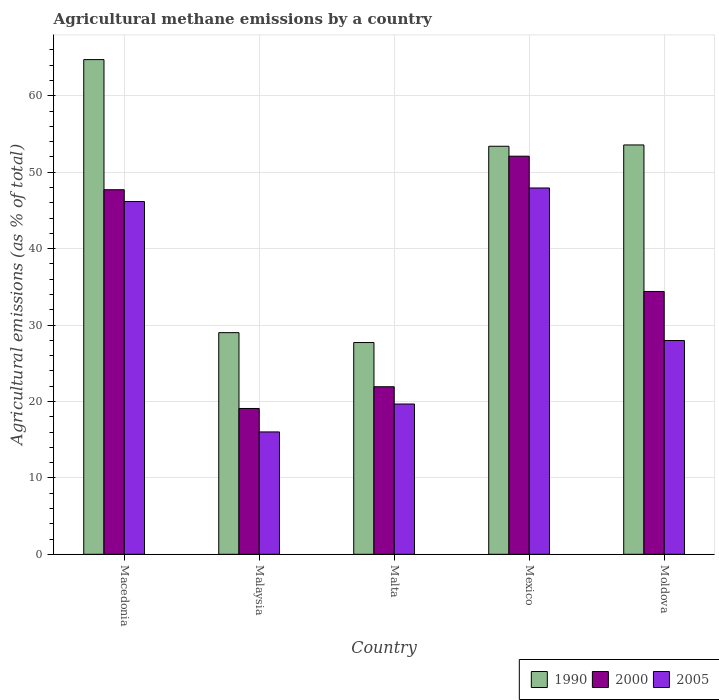How many groups of bars are there?
Your answer should be compact. 5. How many bars are there on the 1st tick from the right?
Keep it short and to the point. 3. What is the label of the 5th group of bars from the left?
Your response must be concise. Moldova. In how many cases, is the number of bars for a given country not equal to the number of legend labels?
Make the answer very short. 0. What is the amount of agricultural methane emitted in 1990 in Malta?
Make the answer very short. 27.71. Across all countries, what is the maximum amount of agricultural methane emitted in 2000?
Your answer should be very brief. 52.09. Across all countries, what is the minimum amount of agricultural methane emitted in 2000?
Your response must be concise. 19.08. In which country was the amount of agricultural methane emitted in 1990 maximum?
Your answer should be very brief. Macedonia. In which country was the amount of agricultural methane emitted in 2000 minimum?
Give a very brief answer. Malaysia. What is the total amount of agricultural methane emitted in 1990 in the graph?
Make the answer very short. 228.4. What is the difference between the amount of agricultural methane emitted in 2005 in Mexico and that in Moldova?
Ensure brevity in your answer.  19.96. What is the difference between the amount of agricultural methane emitted in 2005 in Malta and the amount of agricultural methane emitted in 2000 in Moldova?
Provide a succinct answer. -14.72. What is the average amount of agricultural methane emitted in 2005 per country?
Provide a short and direct response. 31.55. What is the difference between the amount of agricultural methane emitted of/in 2000 and amount of agricultural methane emitted of/in 2005 in Mexico?
Your answer should be very brief. 4.16. What is the ratio of the amount of agricultural methane emitted in 1990 in Macedonia to that in Malaysia?
Give a very brief answer. 2.23. Is the amount of agricultural methane emitted in 1990 in Macedonia less than that in Mexico?
Ensure brevity in your answer.  No. Is the difference between the amount of agricultural methane emitted in 2000 in Malta and Moldova greater than the difference between the amount of agricultural methane emitted in 2005 in Malta and Moldova?
Ensure brevity in your answer.  No. What is the difference between the highest and the second highest amount of agricultural methane emitted in 2005?
Offer a very short reply. -18.19. What is the difference between the highest and the lowest amount of agricultural methane emitted in 1990?
Your response must be concise. 37.02. In how many countries, is the amount of agricultural methane emitted in 1990 greater than the average amount of agricultural methane emitted in 1990 taken over all countries?
Give a very brief answer. 3. Is the sum of the amount of agricultural methane emitted in 2005 in Macedonia and Malta greater than the maximum amount of agricultural methane emitted in 2000 across all countries?
Keep it short and to the point. Yes. Are all the bars in the graph horizontal?
Give a very brief answer. No. How many countries are there in the graph?
Offer a very short reply. 5. Are the values on the major ticks of Y-axis written in scientific E-notation?
Provide a succinct answer. No. Does the graph contain grids?
Your answer should be very brief. Yes. Where does the legend appear in the graph?
Provide a succinct answer. Bottom right. How many legend labels are there?
Offer a very short reply. 3. What is the title of the graph?
Provide a succinct answer. Agricultural methane emissions by a country. Does "2001" appear as one of the legend labels in the graph?
Ensure brevity in your answer.  No. What is the label or title of the Y-axis?
Give a very brief answer. Agricultural emissions (as % of total). What is the Agricultural emissions (as % of total) in 1990 in Macedonia?
Provide a succinct answer. 64.73. What is the Agricultural emissions (as % of total) in 2000 in Macedonia?
Provide a short and direct response. 47.7. What is the Agricultural emissions (as % of total) in 2005 in Macedonia?
Make the answer very short. 46.16. What is the Agricultural emissions (as % of total) in 1990 in Malaysia?
Ensure brevity in your answer.  29. What is the Agricultural emissions (as % of total) in 2000 in Malaysia?
Give a very brief answer. 19.08. What is the Agricultural emissions (as % of total) in 2005 in Malaysia?
Your answer should be very brief. 16.01. What is the Agricultural emissions (as % of total) of 1990 in Malta?
Your answer should be compact. 27.71. What is the Agricultural emissions (as % of total) of 2000 in Malta?
Make the answer very short. 21.92. What is the Agricultural emissions (as % of total) of 2005 in Malta?
Make the answer very short. 19.67. What is the Agricultural emissions (as % of total) in 1990 in Mexico?
Provide a succinct answer. 53.39. What is the Agricultural emissions (as % of total) in 2000 in Mexico?
Make the answer very short. 52.09. What is the Agricultural emissions (as % of total) of 2005 in Mexico?
Offer a terse response. 47.93. What is the Agricultural emissions (as % of total) in 1990 in Moldova?
Give a very brief answer. 53.56. What is the Agricultural emissions (as % of total) of 2000 in Moldova?
Offer a very short reply. 34.39. What is the Agricultural emissions (as % of total) of 2005 in Moldova?
Your answer should be very brief. 27.97. Across all countries, what is the maximum Agricultural emissions (as % of total) of 1990?
Provide a succinct answer. 64.73. Across all countries, what is the maximum Agricultural emissions (as % of total) of 2000?
Give a very brief answer. 52.09. Across all countries, what is the maximum Agricultural emissions (as % of total) of 2005?
Your answer should be very brief. 47.93. Across all countries, what is the minimum Agricultural emissions (as % of total) in 1990?
Offer a terse response. 27.71. Across all countries, what is the minimum Agricultural emissions (as % of total) of 2000?
Provide a short and direct response. 19.08. Across all countries, what is the minimum Agricultural emissions (as % of total) of 2005?
Keep it short and to the point. 16.01. What is the total Agricultural emissions (as % of total) in 1990 in the graph?
Your answer should be very brief. 228.4. What is the total Agricultural emissions (as % of total) of 2000 in the graph?
Provide a succinct answer. 175.19. What is the total Agricultural emissions (as % of total) in 2005 in the graph?
Make the answer very short. 157.74. What is the difference between the Agricultural emissions (as % of total) of 1990 in Macedonia and that in Malaysia?
Provide a succinct answer. 35.73. What is the difference between the Agricultural emissions (as % of total) in 2000 in Macedonia and that in Malaysia?
Your response must be concise. 28.63. What is the difference between the Agricultural emissions (as % of total) in 2005 in Macedonia and that in Malaysia?
Keep it short and to the point. 30.15. What is the difference between the Agricultural emissions (as % of total) of 1990 in Macedonia and that in Malta?
Offer a very short reply. 37.02. What is the difference between the Agricultural emissions (as % of total) of 2000 in Macedonia and that in Malta?
Offer a very short reply. 25.78. What is the difference between the Agricultural emissions (as % of total) in 2005 in Macedonia and that in Malta?
Provide a succinct answer. 26.49. What is the difference between the Agricultural emissions (as % of total) of 1990 in Macedonia and that in Mexico?
Your answer should be compact. 11.34. What is the difference between the Agricultural emissions (as % of total) in 2000 in Macedonia and that in Mexico?
Make the answer very short. -4.39. What is the difference between the Agricultural emissions (as % of total) in 2005 in Macedonia and that in Mexico?
Your response must be concise. -1.77. What is the difference between the Agricultural emissions (as % of total) in 1990 in Macedonia and that in Moldova?
Offer a very short reply. 11.17. What is the difference between the Agricultural emissions (as % of total) of 2000 in Macedonia and that in Moldova?
Your answer should be compact. 13.31. What is the difference between the Agricultural emissions (as % of total) in 2005 in Macedonia and that in Moldova?
Provide a short and direct response. 18.19. What is the difference between the Agricultural emissions (as % of total) of 1990 in Malaysia and that in Malta?
Ensure brevity in your answer.  1.29. What is the difference between the Agricultural emissions (as % of total) in 2000 in Malaysia and that in Malta?
Offer a terse response. -2.84. What is the difference between the Agricultural emissions (as % of total) of 2005 in Malaysia and that in Malta?
Your answer should be very brief. -3.65. What is the difference between the Agricultural emissions (as % of total) in 1990 in Malaysia and that in Mexico?
Offer a terse response. -24.39. What is the difference between the Agricultural emissions (as % of total) in 2000 in Malaysia and that in Mexico?
Give a very brief answer. -33.01. What is the difference between the Agricultural emissions (as % of total) of 2005 in Malaysia and that in Mexico?
Your response must be concise. -31.92. What is the difference between the Agricultural emissions (as % of total) in 1990 in Malaysia and that in Moldova?
Offer a terse response. -24.56. What is the difference between the Agricultural emissions (as % of total) in 2000 in Malaysia and that in Moldova?
Give a very brief answer. -15.31. What is the difference between the Agricultural emissions (as % of total) of 2005 in Malaysia and that in Moldova?
Make the answer very short. -11.96. What is the difference between the Agricultural emissions (as % of total) of 1990 in Malta and that in Mexico?
Your answer should be compact. -25.68. What is the difference between the Agricultural emissions (as % of total) in 2000 in Malta and that in Mexico?
Provide a short and direct response. -30.17. What is the difference between the Agricultural emissions (as % of total) of 2005 in Malta and that in Mexico?
Provide a succinct answer. -28.27. What is the difference between the Agricultural emissions (as % of total) of 1990 in Malta and that in Moldova?
Your answer should be very brief. -25.85. What is the difference between the Agricultural emissions (as % of total) of 2000 in Malta and that in Moldova?
Your answer should be compact. -12.47. What is the difference between the Agricultural emissions (as % of total) in 2005 in Malta and that in Moldova?
Ensure brevity in your answer.  -8.3. What is the difference between the Agricultural emissions (as % of total) of 1990 in Mexico and that in Moldova?
Your response must be concise. -0.17. What is the difference between the Agricultural emissions (as % of total) of 2000 in Mexico and that in Moldova?
Keep it short and to the point. 17.7. What is the difference between the Agricultural emissions (as % of total) of 2005 in Mexico and that in Moldova?
Provide a succinct answer. 19.96. What is the difference between the Agricultural emissions (as % of total) of 1990 in Macedonia and the Agricultural emissions (as % of total) of 2000 in Malaysia?
Provide a succinct answer. 45.65. What is the difference between the Agricultural emissions (as % of total) in 1990 in Macedonia and the Agricultural emissions (as % of total) in 2005 in Malaysia?
Ensure brevity in your answer.  48.72. What is the difference between the Agricultural emissions (as % of total) in 2000 in Macedonia and the Agricultural emissions (as % of total) in 2005 in Malaysia?
Make the answer very short. 31.69. What is the difference between the Agricultural emissions (as % of total) of 1990 in Macedonia and the Agricultural emissions (as % of total) of 2000 in Malta?
Offer a very short reply. 42.81. What is the difference between the Agricultural emissions (as % of total) in 1990 in Macedonia and the Agricultural emissions (as % of total) in 2005 in Malta?
Provide a short and direct response. 45.06. What is the difference between the Agricultural emissions (as % of total) in 2000 in Macedonia and the Agricultural emissions (as % of total) in 2005 in Malta?
Your answer should be very brief. 28.04. What is the difference between the Agricultural emissions (as % of total) of 1990 in Macedonia and the Agricultural emissions (as % of total) of 2000 in Mexico?
Offer a terse response. 12.64. What is the difference between the Agricultural emissions (as % of total) in 1990 in Macedonia and the Agricultural emissions (as % of total) in 2005 in Mexico?
Keep it short and to the point. 16.8. What is the difference between the Agricultural emissions (as % of total) of 2000 in Macedonia and the Agricultural emissions (as % of total) of 2005 in Mexico?
Your answer should be very brief. -0.23. What is the difference between the Agricultural emissions (as % of total) in 1990 in Macedonia and the Agricultural emissions (as % of total) in 2000 in Moldova?
Your response must be concise. 30.34. What is the difference between the Agricultural emissions (as % of total) of 1990 in Macedonia and the Agricultural emissions (as % of total) of 2005 in Moldova?
Provide a short and direct response. 36.76. What is the difference between the Agricultural emissions (as % of total) of 2000 in Macedonia and the Agricultural emissions (as % of total) of 2005 in Moldova?
Your response must be concise. 19.73. What is the difference between the Agricultural emissions (as % of total) in 1990 in Malaysia and the Agricultural emissions (as % of total) in 2000 in Malta?
Ensure brevity in your answer.  7.08. What is the difference between the Agricultural emissions (as % of total) of 1990 in Malaysia and the Agricultural emissions (as % of total) of 2005 in Malta?
Give a very brief answer. 9.34. What is the difference between the Agricultural emissions (as % of total) in 2000 in Malaysia and the Agricultural emissions (as % of total) in 2005 in Malta?
Your answer should be very brief. -0.59. What is the difference between the Agricultural emissions (as % of total) in 1990 in Malaysia and the Agricultural emissions (as % of total) in 2000 in Mexico?
Make the answer very short. -23.09. What is the difference between the Agricultural emissions (as % of total) in 1990 in Malaysia and the Agricultural emissions (as % of total) in 2005 in Mexico?
Give a very brief answer. -18.93. What is the difference between the Agricultural emissions (as % of total) of 2000 in Malaysia and the Agricultural emissions (as % of total) of 2005 in Mexico?
Provide a succinct answer. -28.85. What is the difference between the Agricultural emissions (as % of total) in 1990 in Malaysia and the Agricultural emissions (as % of total) in 2000 in Moldova?
Give a very brief answer. -5.39. What is the difference between the Agricultural emissions (as % of total) of 1990 in Malaysia and the Agricultural emissions (as % of total) of 2005 in Moldova?
Provide a short and direct response. 1.03. What is the difference between the Agricultural emissions (as % of total) of 2000 in Malaysia and the Agricultural emissions (as % of total) of 2005 in Moldova?
Provide a succinct answer. -8.89. What is the difference between the Agricultural emissions (as % of total) of 1990 in Malta and the Agricultural emissions (as % of total) of 2000 in Mexico?
Your answer should be very brief. -24.38. What is the difference between the Agricultural emissions (as % of total) of 1990 in Malta and the Agricultural emissions (as % of total) of 2005 in Mexico?
Give a very brief answer. -20.22. What is the difference between the Agricultural emissions (as % of total) of 2000 in Malta and the Agricultural emissions (as % of total) of 2005 in Mexico?
Keep it short and to the point. -26.01. What is the difference between the Agricultural emissions (as % of total) of 1990 in Malta and the Agricultural emissions (as % of total) of 2000 in Moldova?
Offer a terse response. -6.68. What is the difference between the Agricultural emissions (as % of total) of 1990 in Malta and the Agricultural emissions (as % of total) of 2005 in Moldova?
Your response must be concise. -0.26. What is the difference between the Agricultural emissions (as % of total) of 2000 in Malta and the Agricultural emissions (as % of total) of 2005 in Moldova?
Offer a very short reply. -6.05. What is the difference between the Agricultural emissions (as % of total) of 1990 in Mexico and the Agricultural emissions (as % of total) of 2000 in Moldova?
Give a very brief answer. 19. What is the difference between the Agricultural emissions (as % of total) of 1990 in Mexico and the Agricultural emissions (as % of total) of 2005 in Moldova?
Your answer should be compact. 25.42. What is the difference between the Agricultural emissions (as % of total) of 2000 in Mexico and the Agricultural emissions (as % of total) of 2005 in Moldova?
Keep it short and to the point. 24.12. What is the average Agricultural emissions (as % of total) in 1990 per country?
Ensure brevity in your answer.  45.68. What is the average Agricultural emissions (as % of total) of 2000 per country?
Provide a short and direct response. 35.04. What is the average Agricultural emissions (as % of total) in 2005 per country?
Provide a succinct answer. 31.55. What is the difference between the Agricultural emissions (as % of total) in 1990 and Agricultural emissions (as % of total) in 2000 in Macedonia?
Ensure brevity in your answer.  17.03. What is the difference between the Agricultural emissions (as % of total) in 1990 and Agricultural emissions (as % of total) in 2005 in Macedonia?
Ensure brevity in your answer.  18.57. What is the difference between the Agricultural emissions (as % of total) in 2000 and Agricultural emissions (as % of total) in 2005 in Macedonia?
Offer a very short reply. 1.55. What is the difference between the Agricultural emissions (as % of total) in 1990 and Agricultural emissions (as % of total) in 2000 in Malaysia?
Make the answer very short. 9.92. What is the difference between the Agricultural emissions (as % of total) in 1990 and Agricultural emissions (as % of total) in 2005 in Malaysia?
Your response must be concise. 12.99. What is the difference between the Agricultural emissions (as % of total) in 2000 and Agricultural emissions (as % of total) in 2005 in Malaysia?
Keep it short and to the point. 3.07. What is the difference between the Agricultural emissions (as % of total) of 1990 and Agricultural emissions (as % of total) of 2000 in Malta?
Ensure brevity in your answer.  5.78. What is the difference between the Agricultural emissions (as % of total) of 1990 and Agricultural emissions (as % of total) of 2005 in Malta?
Your answer should be compact. 8.04. What is the difference between the Agricultural emissions (as % of total) of 2000 and Agricultural emissions (as % of total) of 2005 in Malta?
Offer a very short reply. 2.26. What is the difference between the Agricultural emissions (as % of total) in 1990 and Agricultural emissions (as % of total) in 2000 in Mexico?
Make the answer very short. 1.3. What is the difference between the Agricultural emissions (as % of total) in 1990 and Agricultural emissions (as % of total) in 2005 in Mexico?
Provide a short and direct response. 5.46. What is the difference between the Agricultural emissions (as % of total) in 2000 and Agricultural emissions (as % of total) in 2005 in Mexico?
Keep it short and to the point. 4.16. What is the difference between the Agricultural emissions (as % of total) of 1990 and Agricultural emissions (as % of total) of 2000 in Moldova?
Make the answer very short. 19.17. What is the difference between the Agricultural emissions (as % of total) of 1990 and Agricultural emissions (as % of total) of 2005 in Moldova?
Your response must be concise. 25.59. What is the difference between the Agricultural emissions (as % of total) of 2000 and Agricultural emissions (as % of total) of 2005 in Moldova?
Offer a very short reply. 6.42. What is the ratio of the Agricultural emissions (as % of total) of 1990 in Macedonia to that in Malaysia?
Give a very brief answer. 2.23. What is the ratio of the Agricultural emissions (as % of total) in 2000 in Macedonia to that in Malaysia?
Your response must be concise. 2.5. What is the ratio of the Agricultural emissions (as % of total) in 2005 in Macedonia to that in Malaysia?
Provide a succinct answer. 2.88. What is the ratio of the Agricultural emissions (as % of total) in 1990 in Macedonia to that in Malta?
Keep it short and to the point. 2.34. What is the ratio of the Agricultural emissions (as % of total) in 2000 in Macedonia to that in Malta?
Ensure brevity in your answer.  2.18. What is the ratio of the Agricultural emissions (as % of total) in 2005 in Macedonia to that in Malta?
Provide a short and direct response. 2.35. What is the ratio of the Agricultural emissions (as % of total) in 1990 in Macedonia to that in Mexico?
Offer a very short reply. 1.21. What is the ratio of the Agricultural emissions (as % of total) of 2000 in Macedonia to that in Mexico?
Offer a very short reply. 0.92. What is the ratio of the Agricultural emissions (as % of total) of 1990 in Macedonia to that in Moldova?
Offer a terse response. 1.21. What is the ratio of the Agricultural emissions (as % of total) in 2000 in Macedonia to that in Moldova?
Keep it short and to the point. 1.39. What is the ratio of the Agricultural emissions (as % of total) of 2005 in Macedonia to that in Moldova?
Offer a terse response. 1.65. What is the ratio of the Agricultural emissions (as % of total) in 1990 in Malaysia to that in Malta?
Your answer should be compact. 1.05. What is the ratio of the Agricultural emissions (as % of total) in 2000 in Malaysia to that in Malta?
Ensure brevity in your answer.  0.87. What is the ratio of the Agricultural emissions (as % of total) of 2005 in Malaysia to that in Malta?
Your response must be concise. 0.81. What is the ratio of the Agricultural emissions (as % of total) of 1990 in Malaysia to that in Mexico?
Give a very brief answer. 0.54. What is the ratio of the Agricultural emissions (as % of total) of 2000 in Malaysia to that in Mexico?
Your response must be concise. 0.37. What is the ratio of the Agricultural emissions (as % of total) in 2005 in Malaysia to that in Mexico?
Give a very brief answer. 0.33. What is the ratio of the Agricultural emissions (as % of total) of 1990 in Malaysia to that in Moldova?
Offer a terse response. 0.54. What is the ratio of the Agricultural emissions (as % of total) in 2000 in Malaysia to that in Moldova?
Provide a succinct answer. 0.55. What is the ratio of the Agricultural emissions (as % of total) of 2005 in Malaysia to that in Moldova?
Offer a very short reply. 0.57. What is the ratio of the Agricultural emissions (as % of total) of 1990 in Malta to that in Mexico?
Ensure brevity in your answer.  0.52. What is the ratio of the Agricultural emissions (as % of total) in 2000 in Malta to that in Mexico?
Make the answer very short. 0.42. What is the ratio of the Agricultural emissions (as % of total) in 2005 in Malta to that in Mexico?
Offer a very short reply. 0.41. What is the ratio of the Agricultural emissions (as % of total) in 1990 in Malta to that in Moldova?
Your answer should be very brief. 0.52. What is the ratio of the Agricultural emissions (as % of total) of 2000 in Malta to that in Moldova?
Keep it short and to the point. 0.64. What is the ratio of the Agricultural emissions (as % of total) of 2005 in Malta to that in Moldova?
Provide a short and direct response. 0.7. What is the ratio of the Agricultural emissions (as % of total) of 2000 in Mexico to that in Moldova?
Your answer should be very brief. 1.51. What is the ratio of the Agricultural emissions (as % of total) in 2005 in Mexico to that in Moldova?
Offer a terse response. 1.71. What is the difference between the highest and the second highest Agricultural emissions (as % of total) of 1990?
Your answer should be very brief. 11.17. What is the difference between the highest and the second highest Agricultural emissions (as % of total) in 2000?
Make the answer very short. 4.39. What is the difference between the highest and the second highest Agricultural emissions (as % of total) in 2005?
Offer a very short reply. 1.77. What is the difference between the highest and the lowest Agricultural emissions (as % of total) in 1990?
Ensure brevity in your answer.  37.02. What is the difference between the highest and the lowest Agricultural emissions (as % of total) of 2000?
Your answer should be compact. 33.01. What is the difference between the highest and the lowest Agricultural emissions (as % of total) of 2005?
Offer a very short reply. 31.92. 